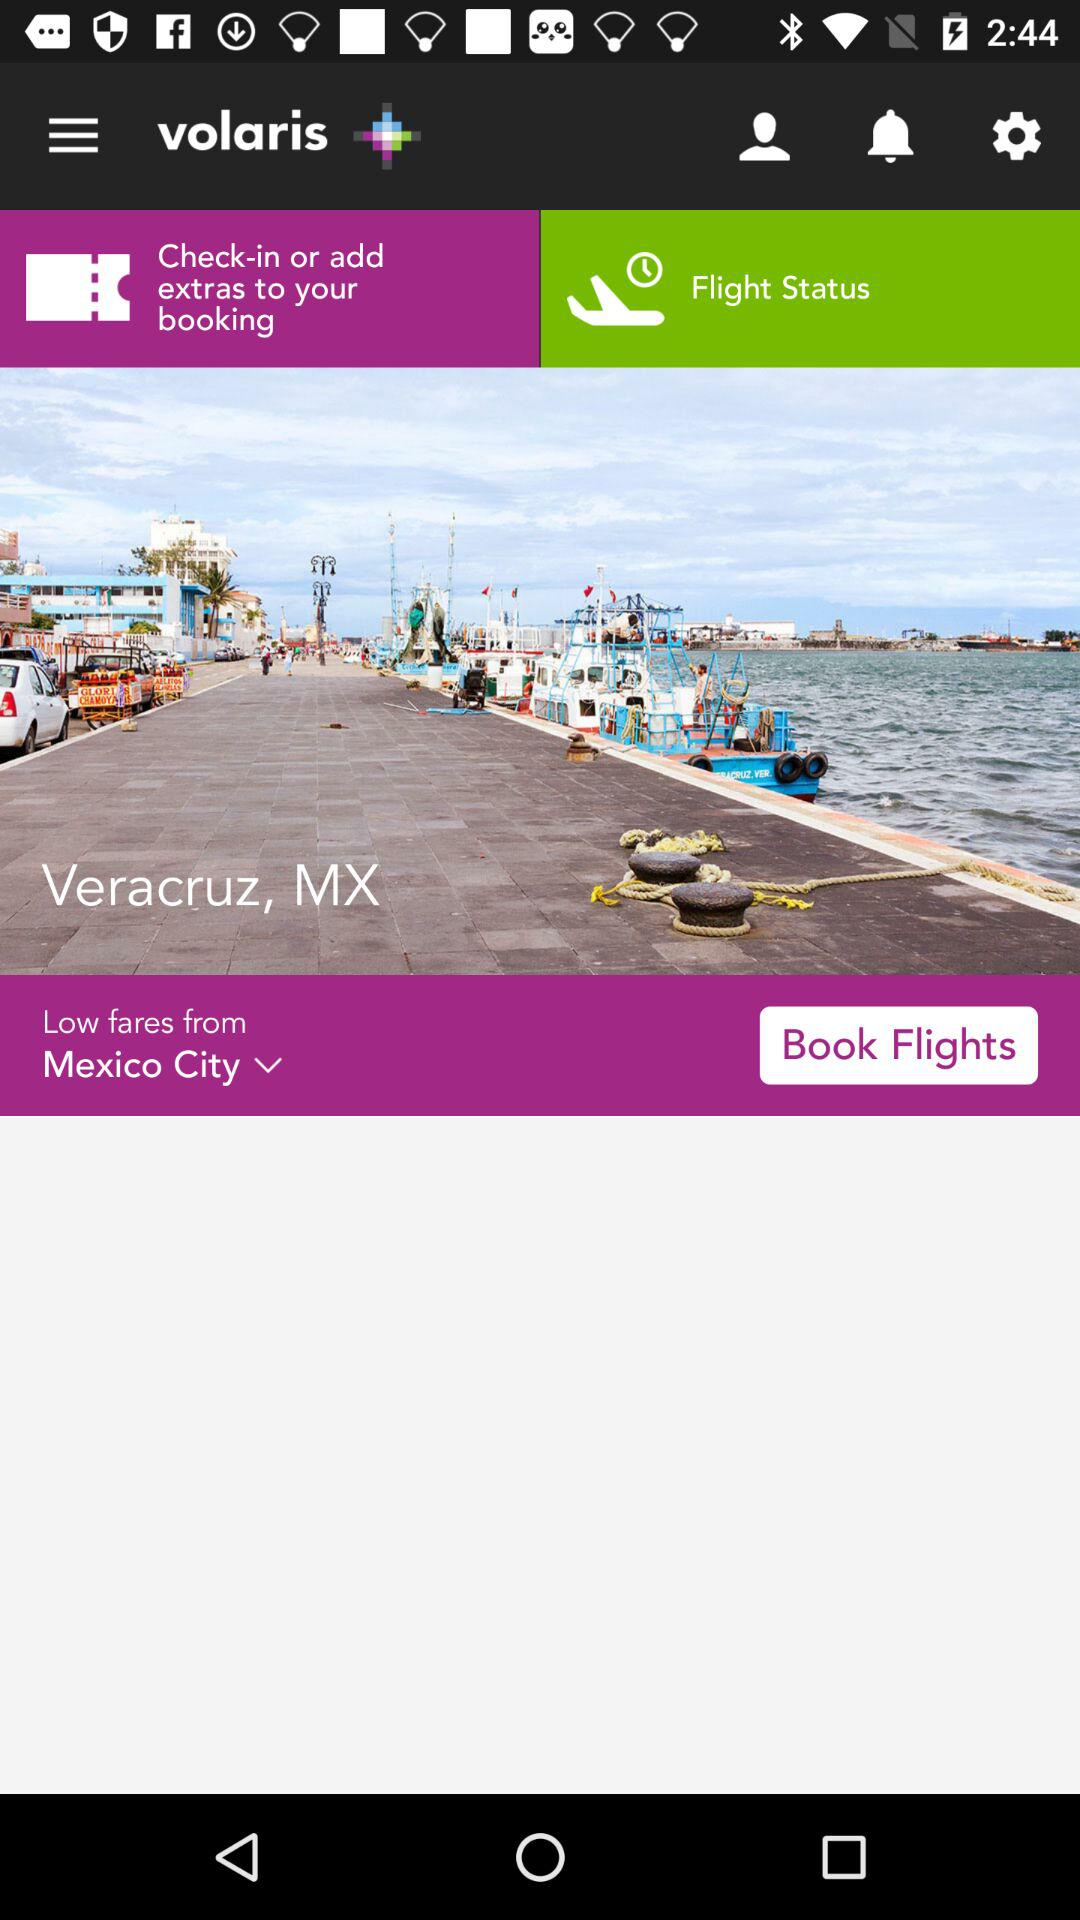What is the application name? The application name is "volaris". 